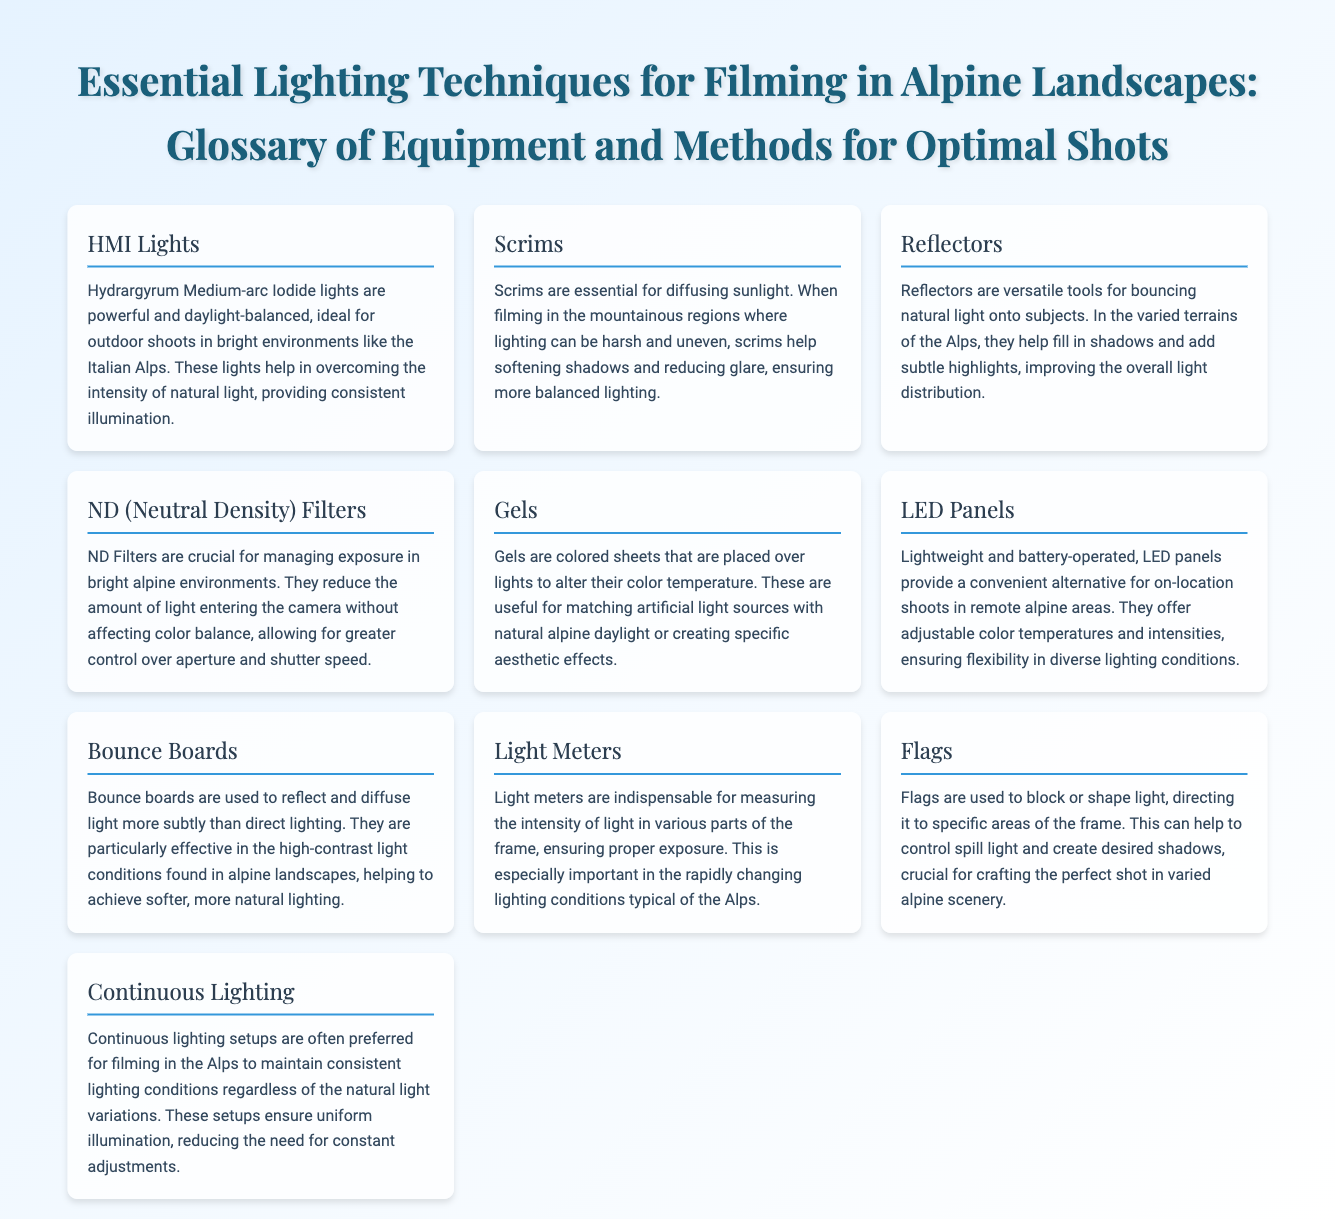What type of lights are HMI Lights? HMI Lights is a term defined in the document as Hydrargyrum Medium-arc Iodide lights, which are powerful and daylight-balanced.
Answer: Hydrargyrum Medium-arc Iodide lights What is the primary use of Scrims? Scrims are defined as essential for diffusing sunlight, particularly to soften shadows and reduce glare in harsh lighting conditions.
Answer: Diffusing sunlight Which tool helps fill in shadows in the Alps? The document states that Reflectors are used for bouncing natural light onto subjects to fill in shadows.
Answer: Reflectors What do ND Filters manage in alpine environments? ND Filters are crucial for managing exposure, as detailed in the document, specifically in bright alpine environments.
Answer: Exposure What kind of lighting setups are favored for consistency in the Alps? Continuous Lighting is mentioned in the document as a preferred setup to maintain consistent lighting conditions.
Answer: Continuous Lighting How do Gels modify light? Gels are described as colored sheets placed over lights to alter their color temperature, useful for matching light sources.
Answer: Altering color temperature What do Light Meters measure? Light Meters are indispensable for measuring light intensity, ensuring proper exposure in the frame.
Answer: Light intensity What is a key benefit of LED Panels mentioned? LED Panels are highlighted for being lightweight and battery-operated, making them convenient for on-location shoots.
Answer: Lightweight and battery-operated What is the function of Flags according to the document? Flags are used to block or shape light and direct it to specific areas of the frame, as explained in the document.
Answer: Blocking or shaping light 